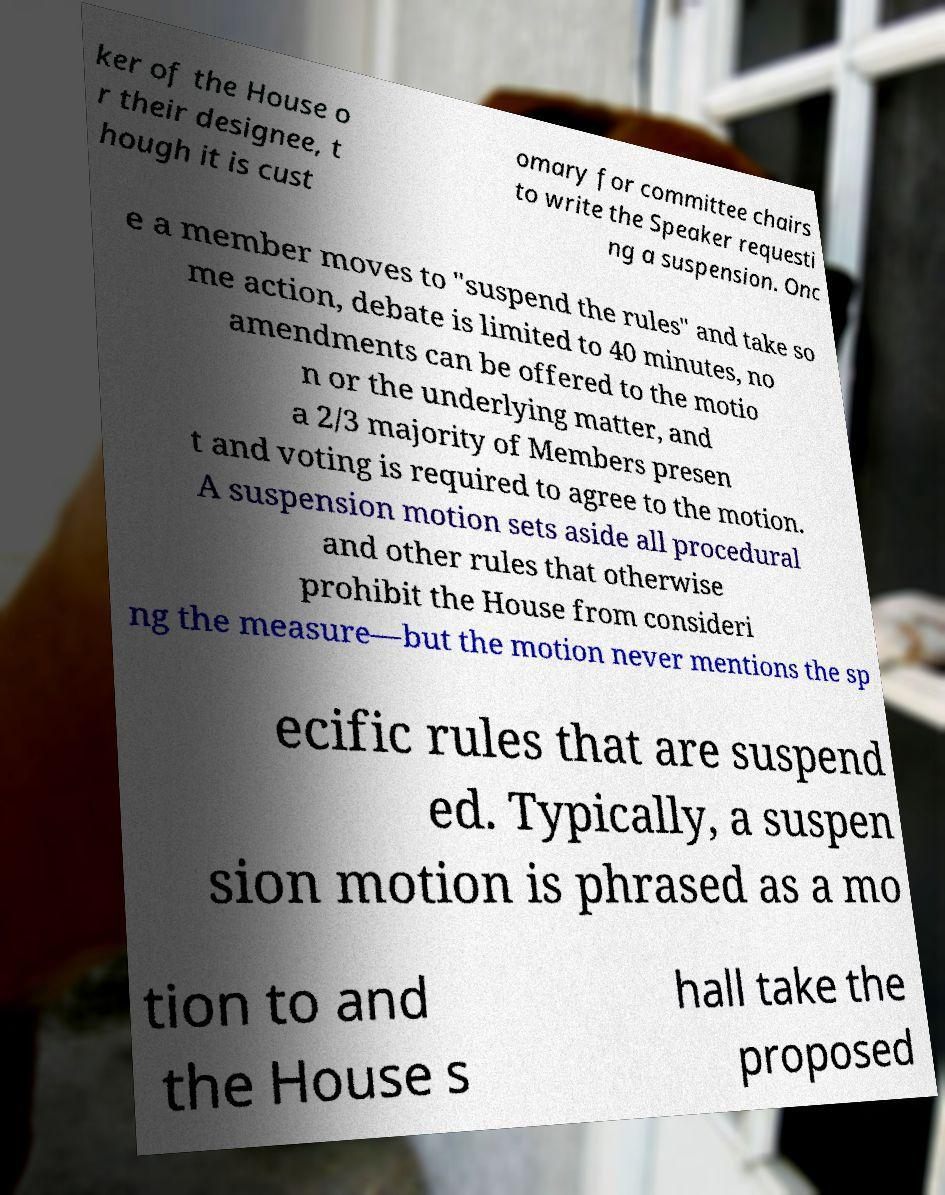There's text embedded in this image that I need extracted. Can you transcribe it verbatim? ker of the House o r their designee, t hough it is cust omary for committee chairs to write the Speaker requesti ng a suspension. Onc e a member moves to "suspend the rules" and take so me action, debate is limited to 40 minutes, no amendments can be offered to the motio n or the underlying matter, and a 2/3 majority of Members presen t and voting is required to agree to the motion. A suspension motion sets aside all procedural and other rules that otherwise prohibit the House from consideri ng the measure—but the motion never mentions the sp ecific rules that are suspend ed. Typically, a suspen sion motion is phrased as a mo tion to and the House s hall take the proposed 